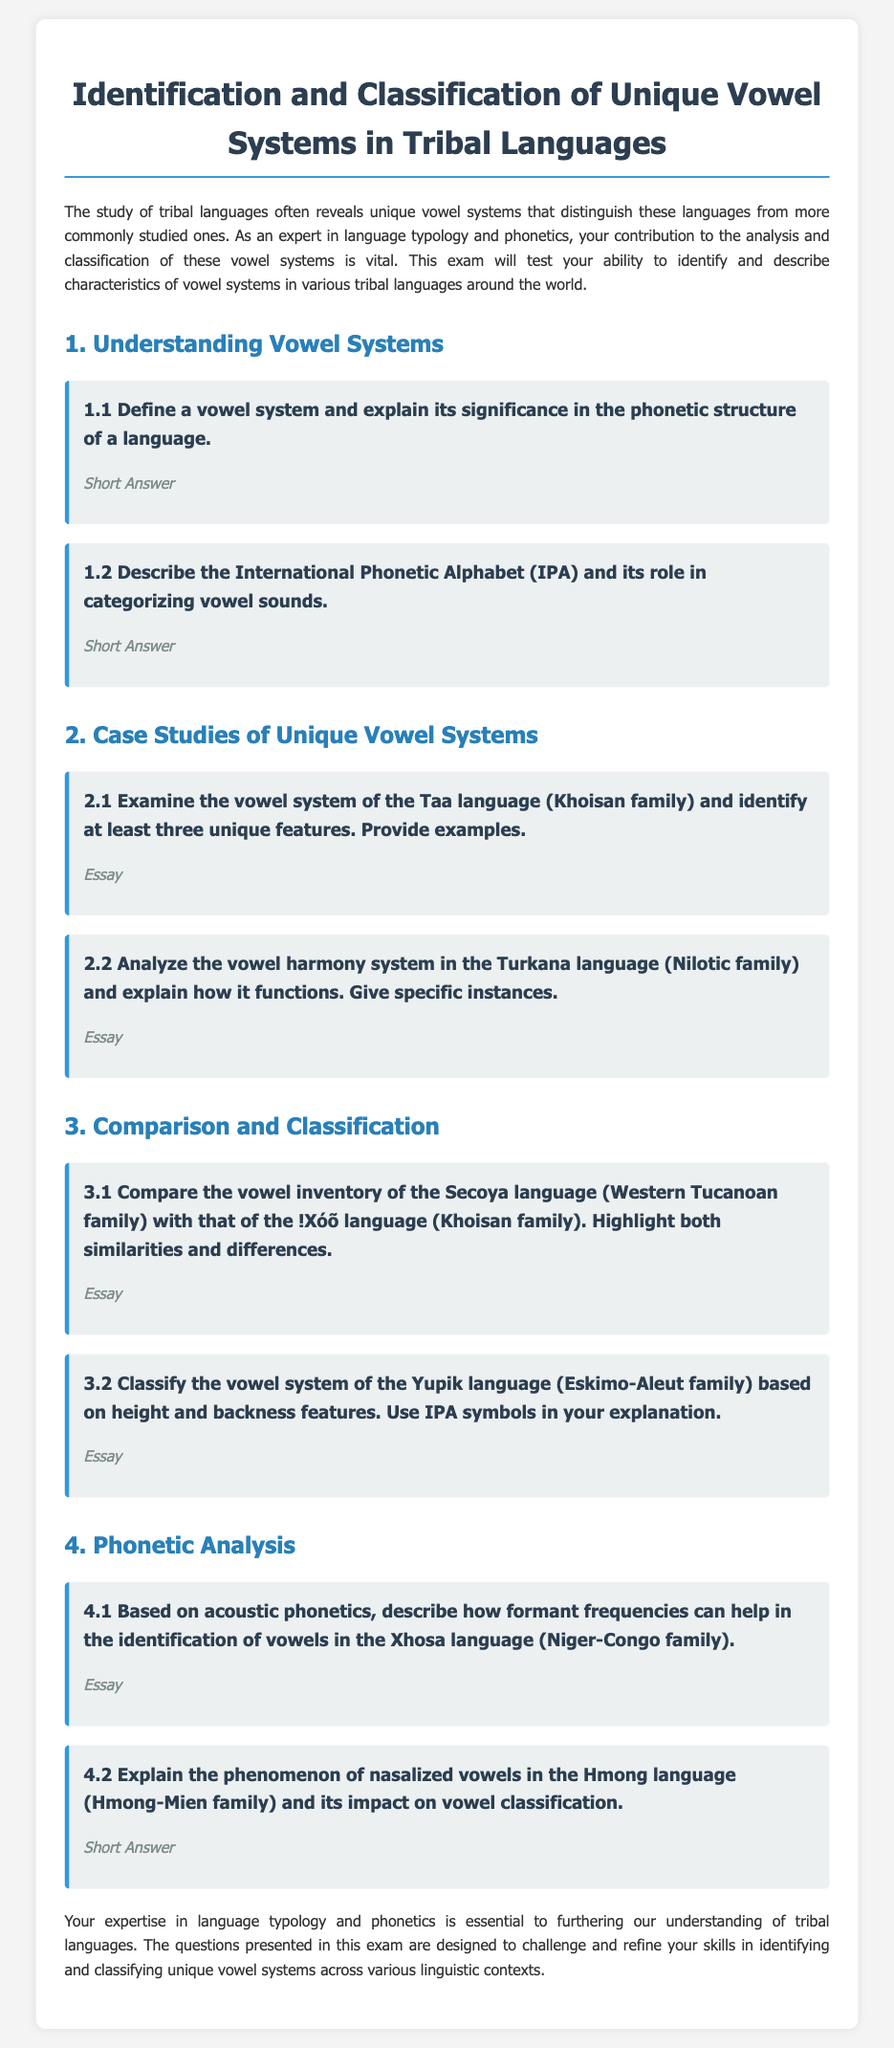what is the title of the exam? The title of the exam is given at the top of the document.
Answer: Identification and Classification of Unique Vowel Systems in Tribal Languages how many sections are in the document? The document is divided into four main sections detailing different aspects of vowel systems.
Answer: 4 what is the first question in the Understanding Vowel Systems section? The first question is the initial inquiry within the specified section.
Answer: Define a vowel system and explain its significance in the phonetic structure of a language which language is analyzed in question 2.1? Question 2.1 specifically examines the vowel system of one particular language.
Answer: Taa what type of question is in section 4.2? The question type refers to the expected answer format specified for that particular question.
Answer: Short Answer which family of languages does the Yupik language belong to? The family of languages is mentioned as part of the classification question for Yupik.
Answer: Eskimo-Aleut 